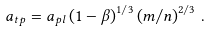<formula> <loc_0><loc_0><loc_500><loc_500>a _ { t p } = a _ { p l } \left ( 1 - \beta \right ) ^ { 1 / 3 } \left ( m / n \right ) ^ { 2 / 3 } \, .</formula> 